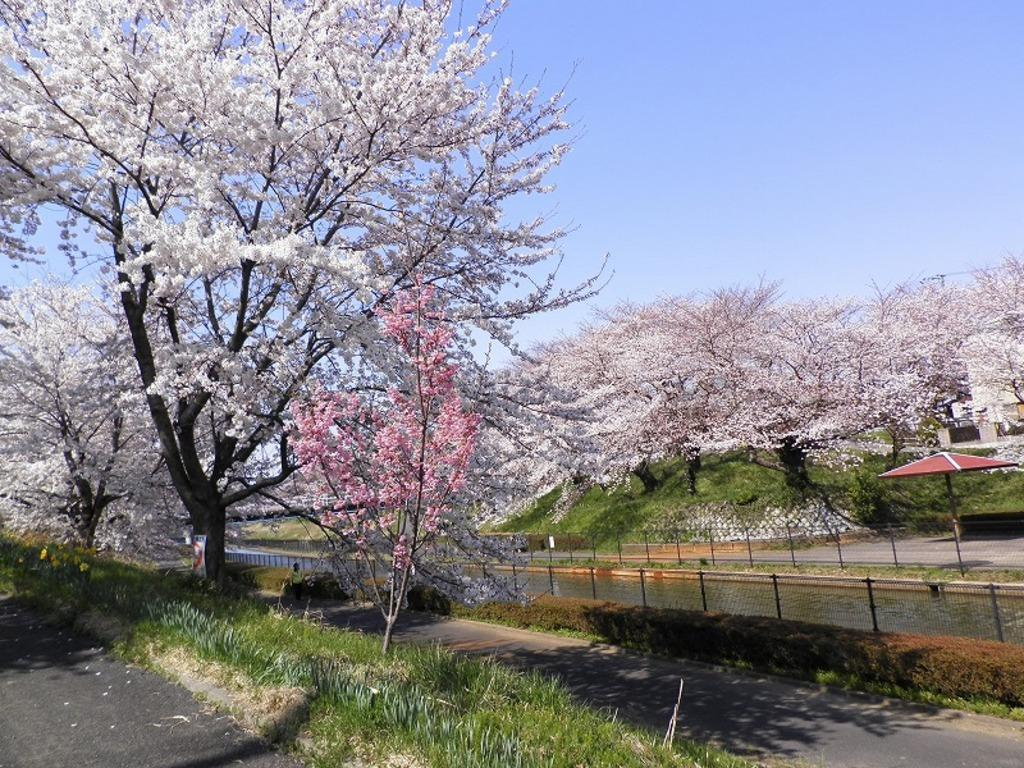What type of vegetation can be seen in the image? There are plants, grass, and flowers in the image. What is the purpose of the fence in the image? The fence in the image serves as a boundary or barrier. What can be seen in the background of the image? The sky is visible in the background of the image. What type of anger is being displayed by the sock in the image? There is no sock present in the image, and therefore no anger can be observed. 